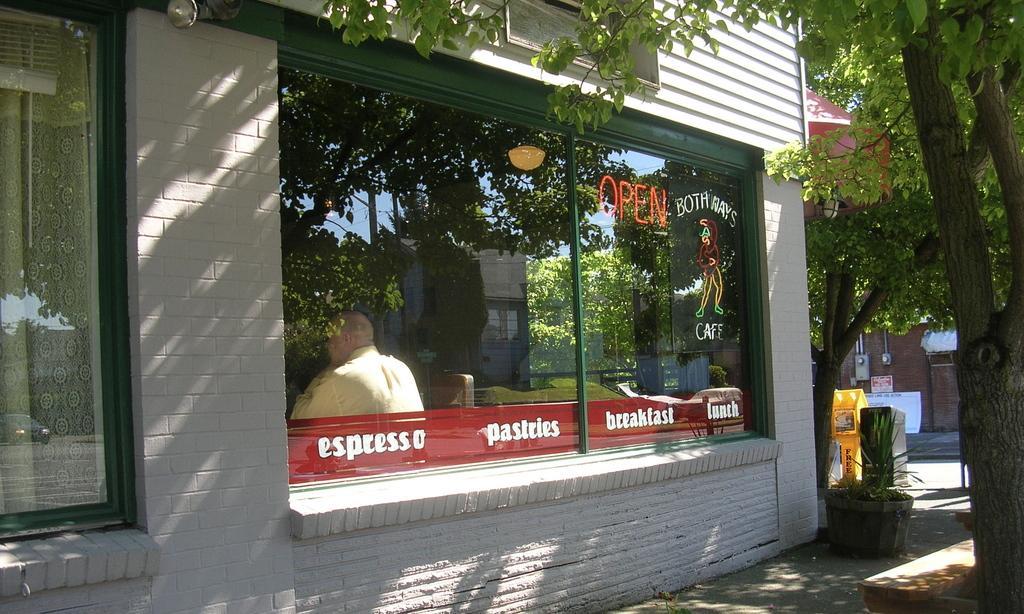In one or two sentences, can you explain what this image depicts? In this image in front there is a building. There are glass windows through which we can see a person sitting on the chair. On the right side of the image there are trees. There is a flower pot. There are dustbins. In the center of the image there is a road. In the background of the image there is a building. 